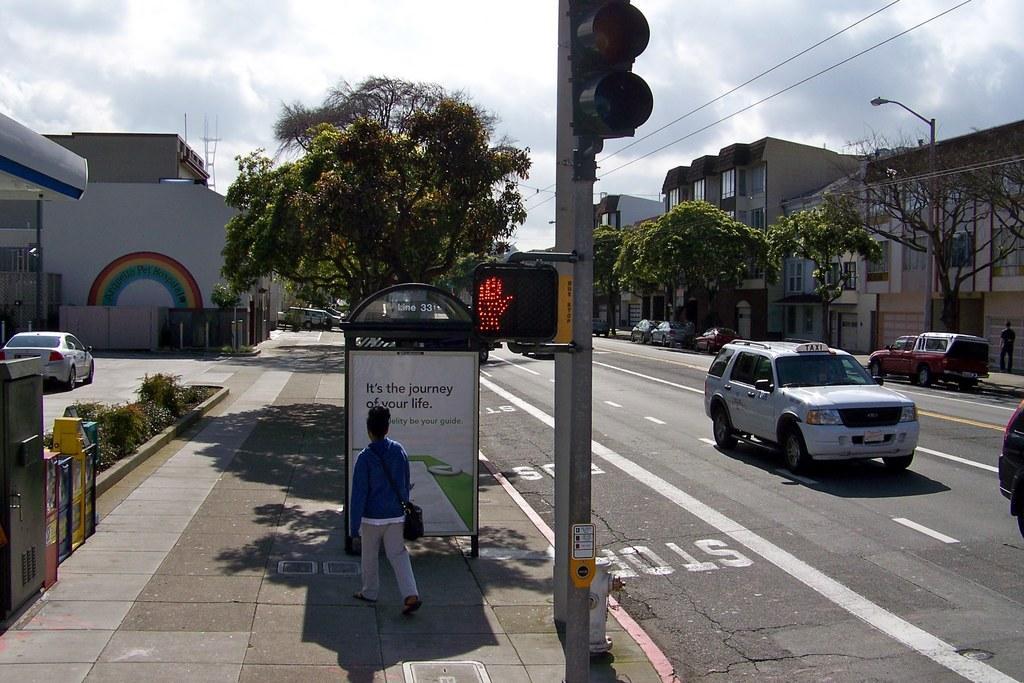Could you give a brief overview of what you see in this image? In this image, at the bottom there is a person, walking. In the middle there are cars, traffic signals, trees, buildings, cables, posters, board, text, plants, road, people, street lights. At the top there are clouds and sky. 